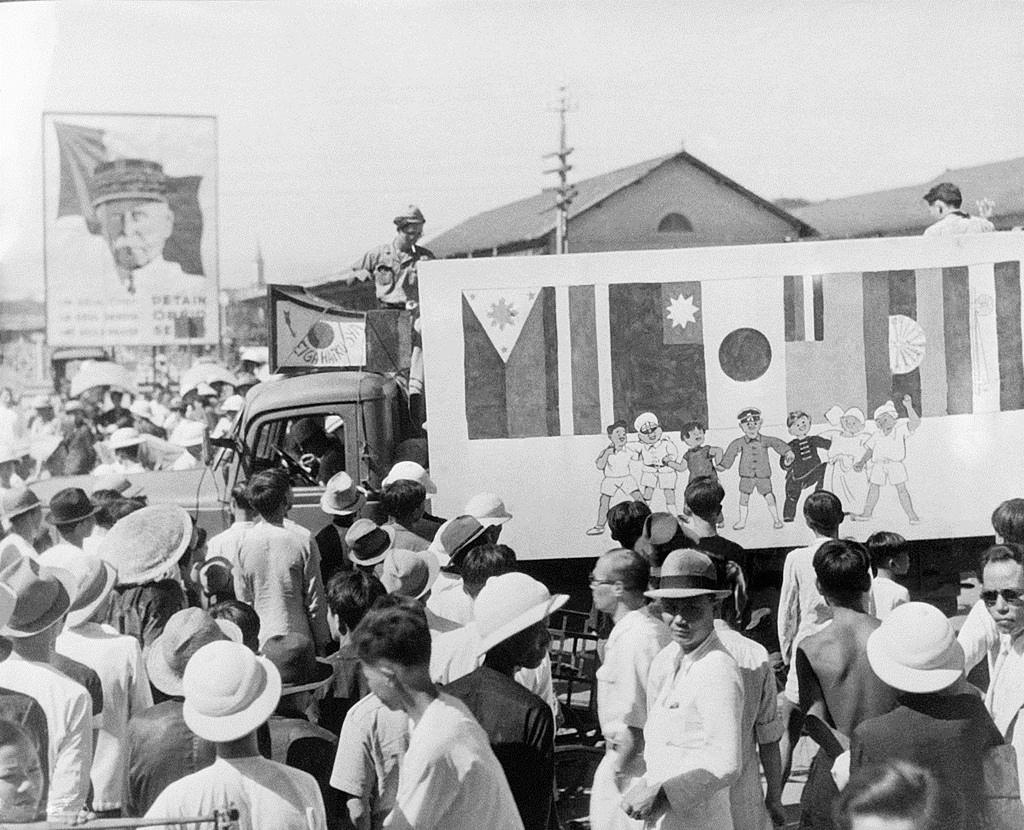What is the color scheme of the image? The image is black and white. What type of objects can be seen on the walls in the image? There are posters in the image. What type of structures are visible in the image? There are buildings in the image. What type of street furniture can be seen in the image? There are street poles in the image. What type of transportation is present in the image? There are motor vehicles in the image. What type of people can be seen in the image? There are persons on the ground in the image. What part of the natural environment is visible in the image? The sky is visible in the image. Where can the twig be found in the image? There is no twig present in the image. What type of can is visible in the image? There is no can present in the image. 